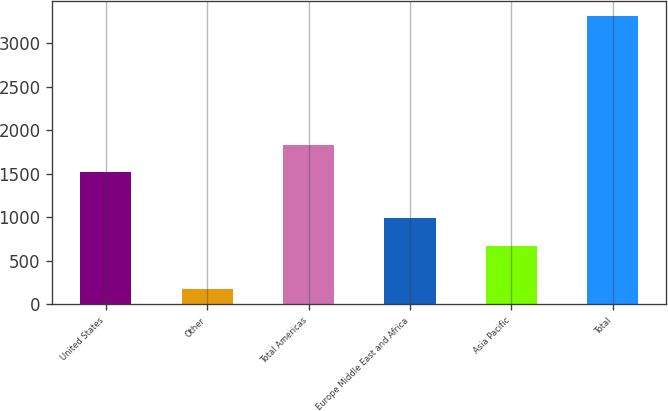Convert chart. <chart><loc_0><loc_0><loc_500><loc_500><bar_chart><fcel>United States<fcel>Other<fcel>Total Americas<fcel>Europe Middle East and Africa<fcel>Asia Pacific<fcel>Total<nl><fcel>1515.1<fcel>172.8<fcel>1829.41<fcel>989.11<fcel>674.8<fcel>3315.9<nl></chart> 